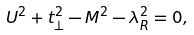<formula> <loc_0><loc_0><loc_500><loc_500>U ^ { 2 } + t _ { \perp } ^ { 2 } - M ^ { 2 } - \lambda _ { R } ^ { 2 } = 0 ,</formula> 